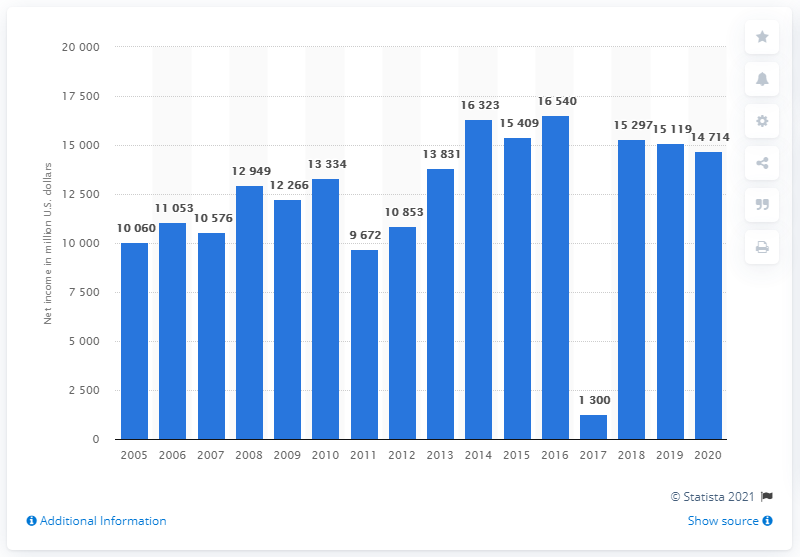Highlight a few significant elements in this photo. The previous year's net income for Johnson & Johnson was 151,191. Johnson & Johnson's net earnings in 2020 were $14,714. 